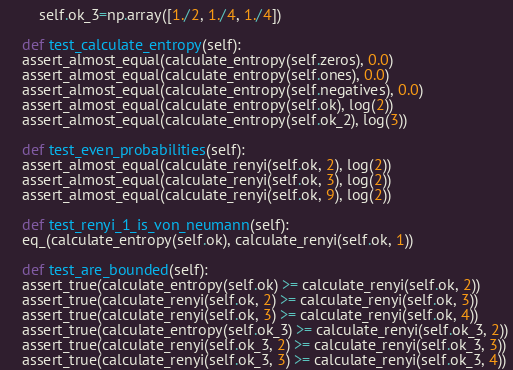Convert code to text. <code><loc_0><loc_0><loc_500><loc_500><_Python_>        self.ok_3=np.array([1./2, 1./4, 1./4])

    def test_calculate_entropy(self):
	assert_almost_equal(calculate_entropy(self.zeros), 0.0)
	assert_almost_equal(calculate_entropy(self.ones), 0.0)
	assert_almost_equal(calculate_entropy(self.negatives), 0.0)
	assert_almost_equal(calculate_entropy(self.ok), log(2))
	assert_almost_equal(calculate_entropy(self.ok_2), log(3))

    def test_even_probabilities(self):
	assert_almost_equal(calculate_renyi(self.ok, 2), log(2))
	assert_almost_equal(calculate_renyi(self.ok, 3), log(2))
	assert_almost_equal(calculate_renyi(self.ok, 9), log(2))

    def test_renyi_1_is_von_neumann(self):
	eq_(calculate_entropy(self.ok), calculate_renyi(self.ok, 1))
    
    def test_are_bounded(self):
	assert_true(calculate_entropy(self.ok) >= calculate_renyi(self.ok, 2))
	assert_true(calculate_renyi(self.ok, 2) >= calculate_renyi(self.ok, 3))
	assert_true(calculate_renyi(self.ok, 3) >= calculate_renyi(self.ok, 4))
	assert_true(calculate_entropy(self.ok_3) >= calculate_renyi(self.ok_3, 2))
	assert_true(calculate_renyi(self.ok_3, 2) >= calculate_renyi(self.ok_3, 3))
	assert_true(calculate_renyi(self.ok_3, 3) >= calculate_renyi(self.ok_3, 4))
</code> 